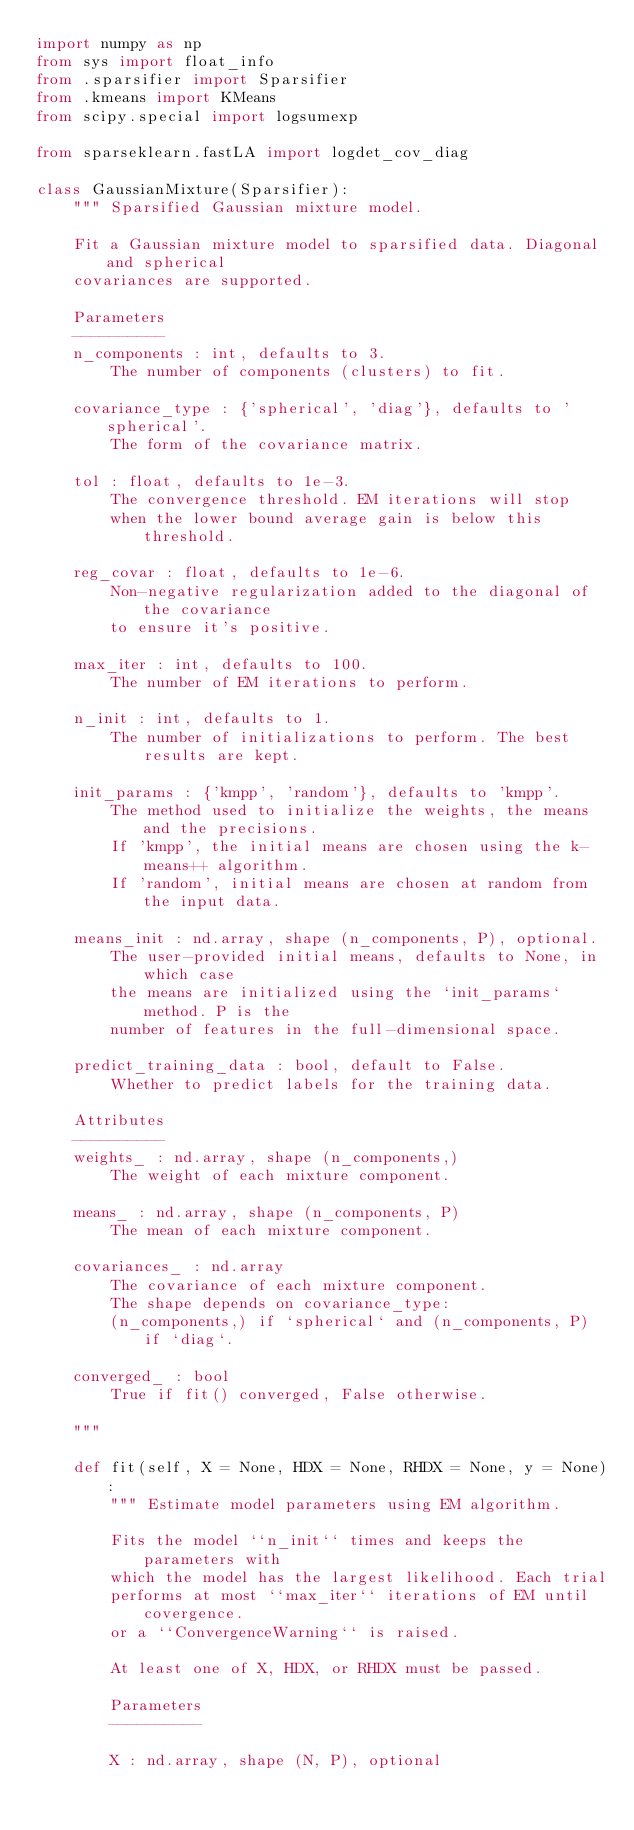<code> <loc_0><loc_0><loc_500><loc_500><_Python_>import numpy as np
from sys import float_info
from .sparsifier import Sparsifier
from .kmeans import KMeans
from scipy.special import logsumexp

from sparseklearn.fastLA import logdet_cov_diag

class GaussianMixture(Sparsifier):
    """ Sparsified Gaussian mixture model.

    Fit a Gaussian mixture model to sparsified data. Diagonal and spherical
    covariances are supported.

    Parameters
    ----------
    n_components : int, defaults to 3.
        The number of components (clusters) to fit.

    covariance_type : {'spherical', 'diag'}, defaults to 'spherical'.
        The form of the covariance matrix.

    tol : float, defaults to 1e-3.
        The convergence threshold. EM iterations will stop
        when the lower bound average gain is below this threshold.

    reg_covar : float, defaults to 1e-6.
        Non-negative regularization added to the diagonal of the covariance
        to ensure it's positive.

    max_iter : int, defaults to 100.
        The number of EM iterations to perform.

    n_init : int, defaults to 1.
        The number of initializations to perform. The best results are kept.

    init_params : {'kmpp', 'random'}, defaults to 'kmpp'.
        The method used to initialize the weights, the means and the precisions.
        If 'kmpp', the initial means are chosen using the k-means++ algorithm.
        If 'random', initial means are chosen at random from the input data.

    means_init : nd.array, shape (n_components, P), optional.
        The user-provided initial means, defaults to None, in which case
        the means are initialized using the `init_params` method. P is the
        number of features in the full-dimensional space.

    predict_training_data : bool, default to False.
        Whether to predict labels for the training data.

    Attributes
    ----------
    weights_ : nd.array, shape (n_components,)
        The weight of each mixture component.

    means_ : nd.array, shape (n_components, P)
        The mean of each mixture component.

    covariances_ : nd.array
        The covariance of each mixture component.
        The shape depends on covariance_type:
        (n_components,) if `spherical` and (n_components, P) if `diag`.

    converged_ : bool
        True if fit() converged, False otherwise.

    """

    def fit(self, X = None, HDX = None, RHDX = None, y = None):
        """ Estimate model parameters using EM algorithm.

        Fits the model ``n_init`` times and keeps the parameters with
        which the model has the largest likelihood. Each trial
        performs at most ``max_iter`` iterations of EM until covergence.
        or a ``ConvergenceWarning`` is raised.

        At least one of X, HDX, or RHDX must be passed.

        Parameters
        ----------

        X : nd.array, shape (N, P), optional</code> 